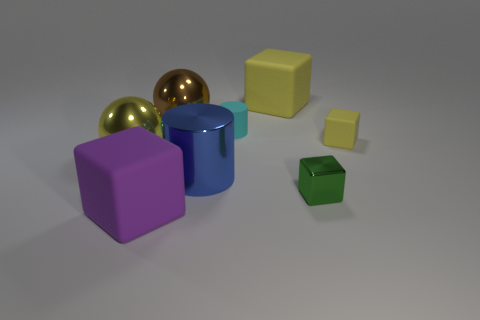Are there any rubber things of the same color as the rubber cylinder?
Provide a short and direct response. No. What number of big rubber things are there?
Your answer should be very brief. 2. There is a big cube that is to the right of the big matte thing that is in front of the yellow cube left of the tiny metallic cube; what is its material?
Offer a terse response. Rubber. Are there any cylinders made of the same material as the green cube?
Offer a terse response. Yes. Is the small cyan cylinder made of the same material as the brown object?
Your answer should be compact. No. What number of blocks are either tiny metal objects or tiny cyan matte things?
Give a very brief answer. 1. The small block that is made of the same material as the large brown ball is what color?
Ensure brevity in your answer.  Green. Are there fewer brown things than big yellow matte balls?
Provide a succinct answer. No. There is a green object that is in front of the small yellow matte thing; is it the same shape as the big matte thing in front of the large blue cylinder?
Keep it short and to the point. Yes. What number of things are either large blue rubber blocks or rubber cylinders?
Provide a succinct answer. 1. 